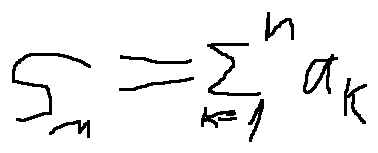Convert formula to latex. <formula><loc_0><loc_0><loc_500><loc_500>s _ { n } = \sum \lim i t s _ { k = 1 } ^ { n } a _ { k }</formula> 